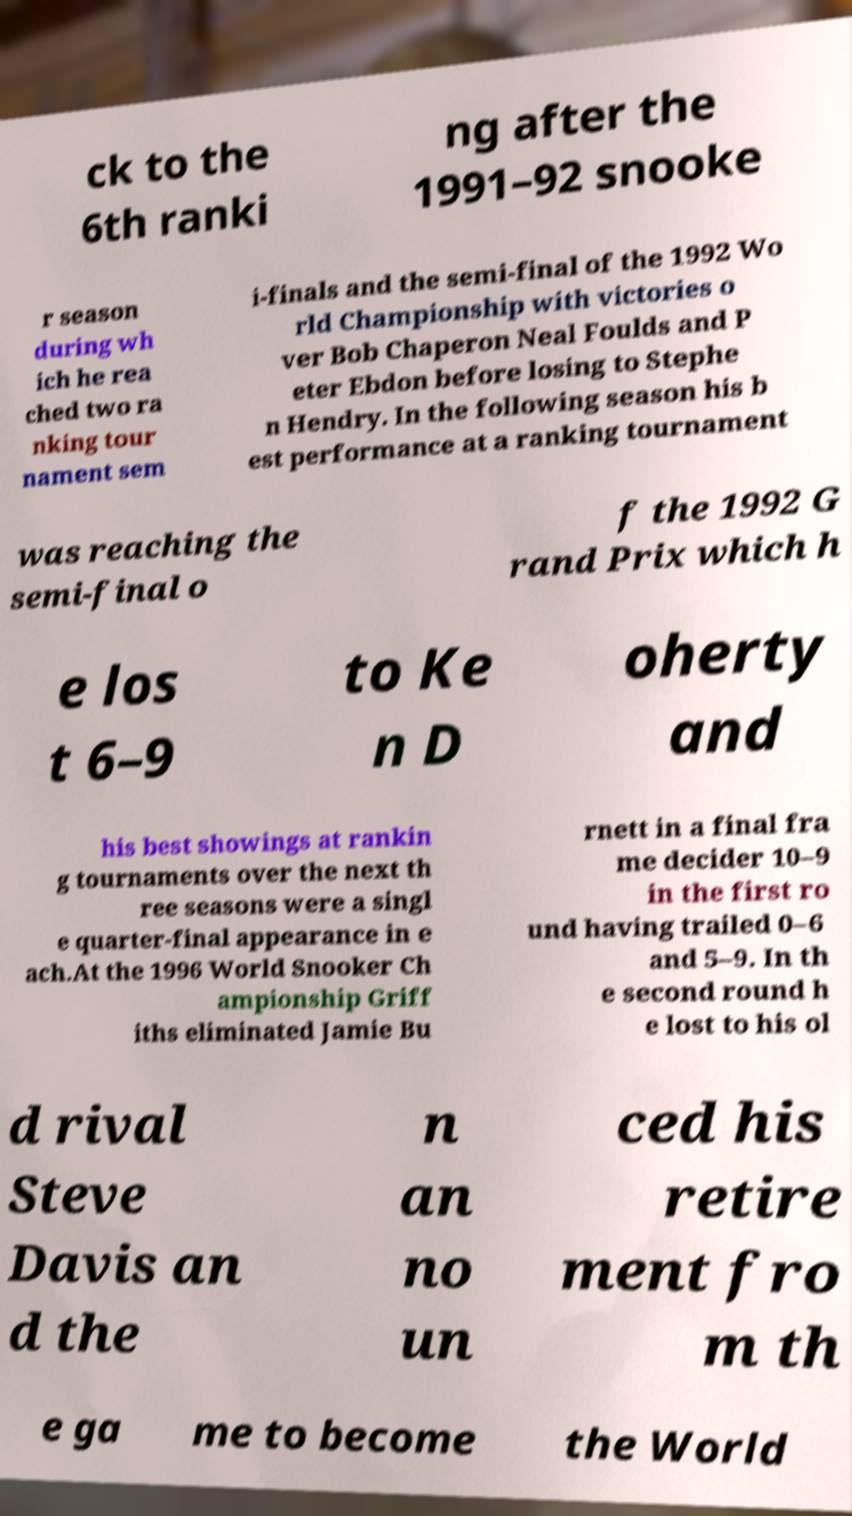Can you read and provide the text displayed in the image?This photo seems to have some interesting text. Can you extract and type it out for me? ck to the 6th ranki ng after the 1991–92 snooke r season during wh ich he rea ched two ra nking tour nament sem i-finals and the semi-final of the 1992 Wo rld Championship with victories o ver Bob Chaperon Neal Foulds and P eter Ebdon before losing to Stephe n Hendry. In the following season his b est performance at a ranking tournament was reaching the semi-final o f the 1992 G rand Prix which h e los t 6–9 to Ke n D oherty and his best showings at rankin g tournaments over the next th ree seasons were a singl e quarter-final appearance in e ach.At the 1996 World Snooker Ch ampionship Griff iths eliminated Jamie Bu rnett in a final fra me decider 10–9 in the first ro und having trailed 0–6 and 5–9. In th e second round h e lost to his ol d rival Steve Davis an d the n an no un ced his retire ment fro m th e ga me to become the World 